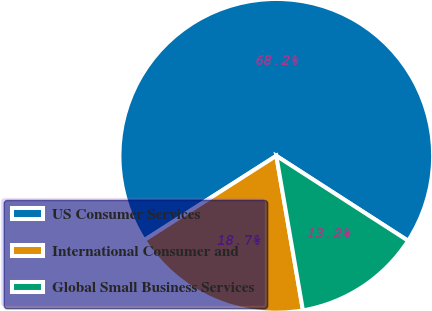<chart> <loc_0><loc_0><loc_500><loc_500><pie_chart><fcel>US Consumer Services<fcel>International Consumer and<fcel>Global Small Business Services<nl><fcel>68.16%<fcel>18.67%<fcel>13.17%<nl></chart> 